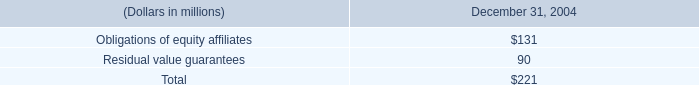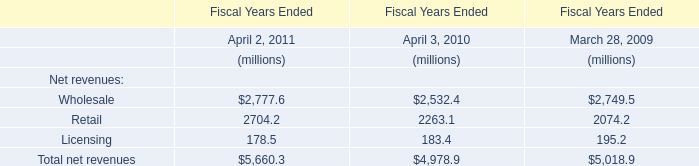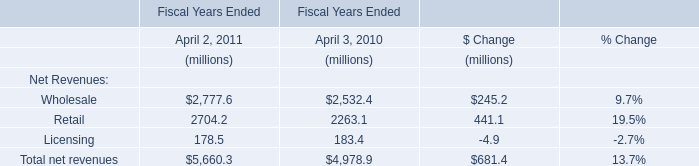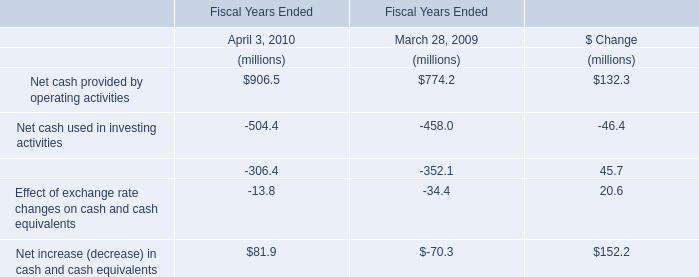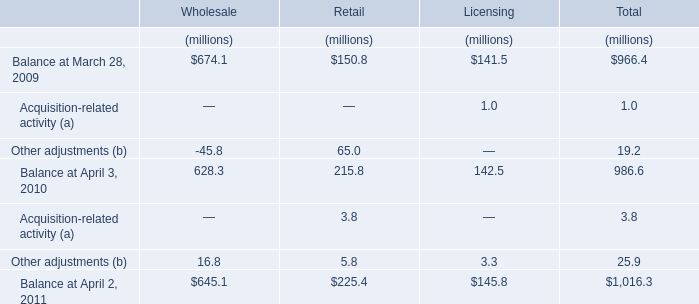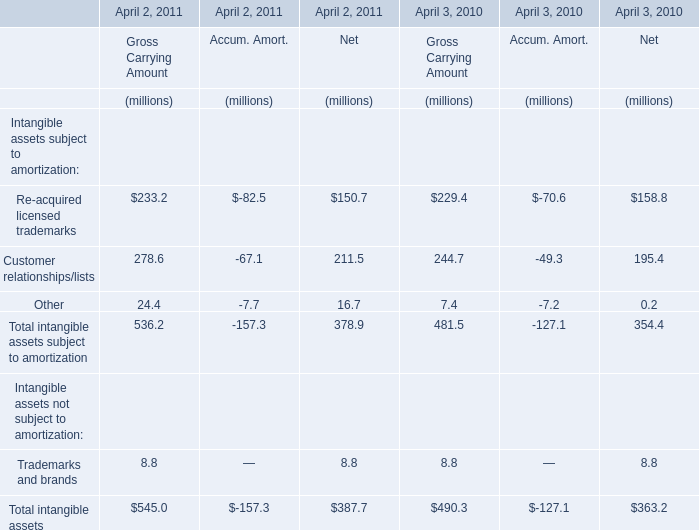What's the total amount of the Balance at March 28, 2009 and Other adjustments in the years where Other adjustments is greater than 60 ? (in million) 
Computations: (150.8 + 65)
Answer: 215.8. 